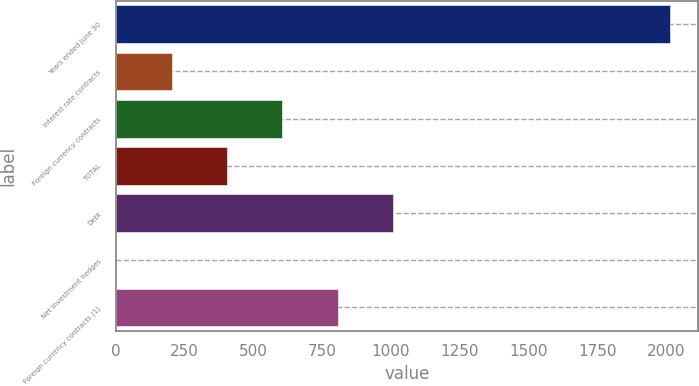Convert chart to OTSL. <chart><loc_0><loc_0><loc_500><loc_500><bar_chart><fcel>Years ended June 30<fcel>Interest rate contracts<fcel>Foreign currency contracts<fcel>TOTAL<fcel>Debt<fcel>Net investment hedges<fcel>Foreign currency contracts (1)<nl><fcel>2016<fcel>203.4<fcel>606.2<fcel>404.8<fcel>1009<fcel>2<fcel>807.6<nl></chart> 